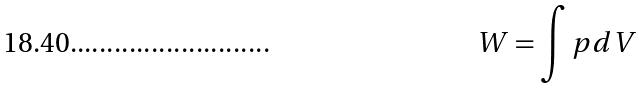Convert formula to latex. <formula><loc_0><loc_0><loc_500><loc_500>W = \int p d V</formula> 